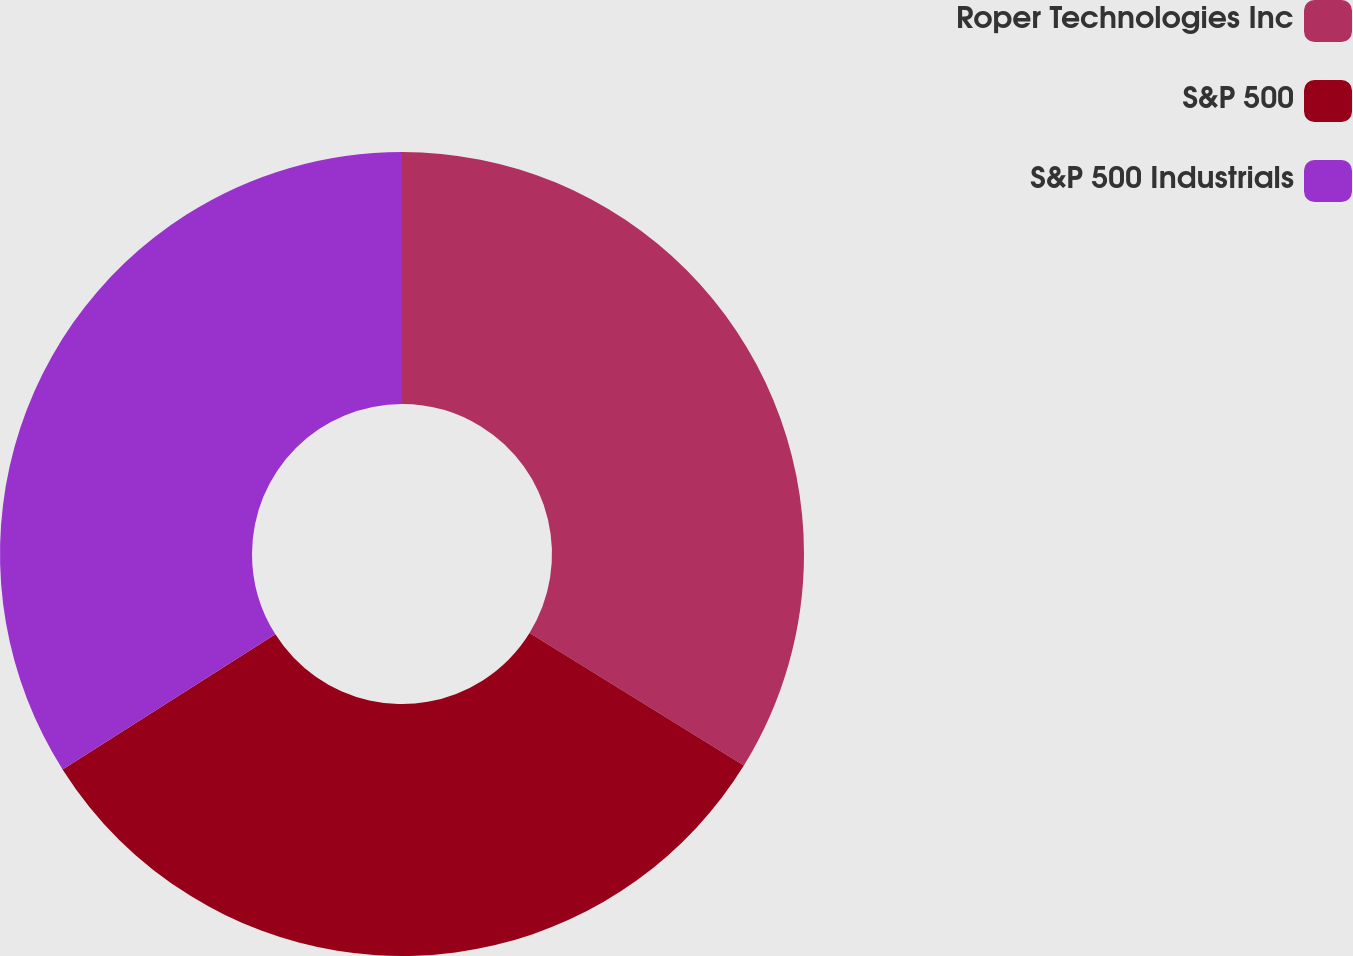Convert chart to OTSL. <chart><loc_0><loc_0><loc_500><loc_500><pie_chart><fcel>Roper Technologies Inc<fcel>S&P 500<fcel>S&P 500 Industrials<nl><fcel>33.82%<fcel>32.18%<fcel>34.0%<nl></chart> 